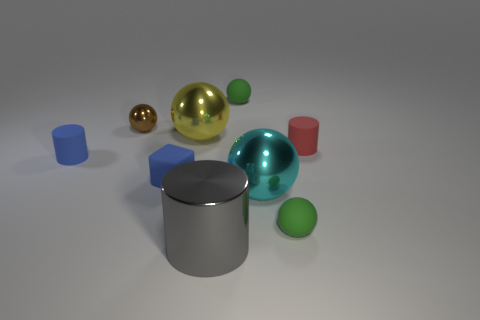Subtract all brown spheres. How many spheres are left? 4 Subtract all brown balls. How many balls are left? 4 Subtract 2 spheres. How many spheres are left? 3 Subtract all blue spheres. Subtract all brown cylinders. How many spheres are left? 5 Subtract all balls. How many objects are left? 4 Subtract 1 brown balls. How many objects are left? 8 Subtract all big yellow shiny things. Subtract all red cylinders. How many objects are left? 7 Add 2 metal cylinders. How many metal cylinders are left? 3 Add 7 blue blocks. How many blue blocks exist? 8 